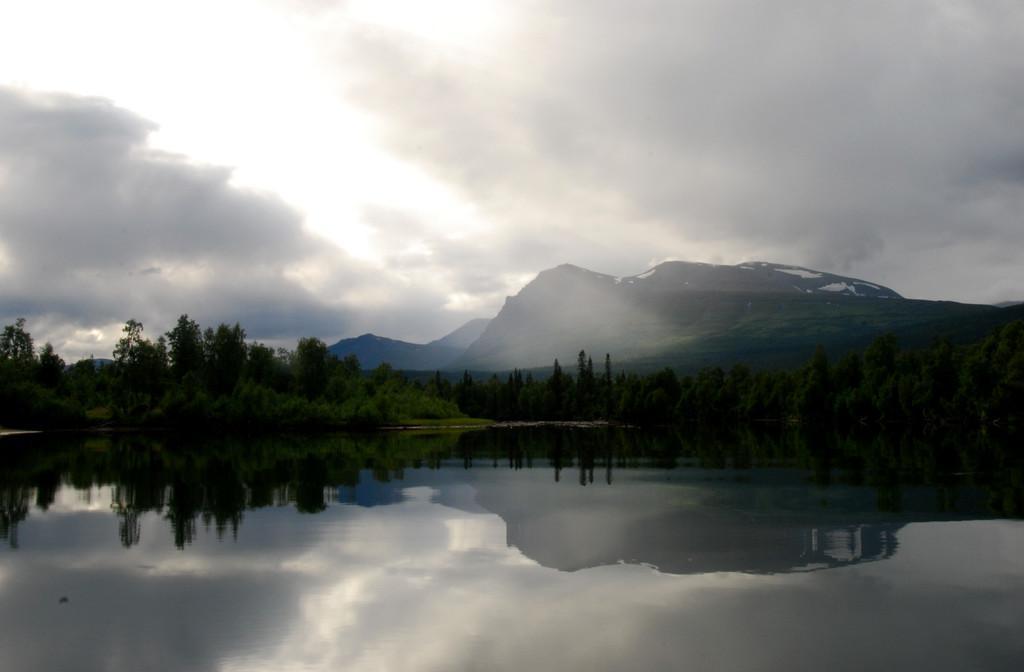Can you describe this image briefly? In the picture we can see water and behind it, we can plant, trees, hills and some part of snow on it and behind it we can see a sky with clouds. 